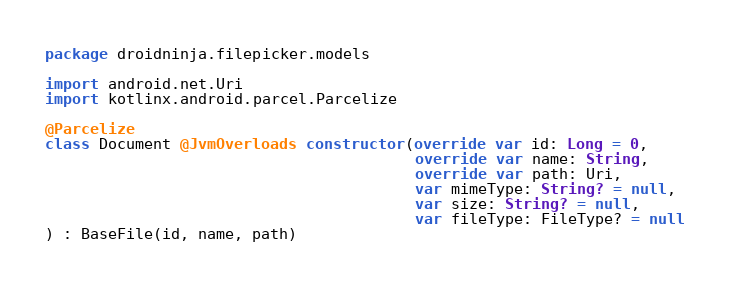Convert code to text. <code><loc_0><loc_0><loc_500><loc_500><_Kotlin_>package droidninja.filepicker.models

import android.net.Uri
import kotlinx.android.parcel.Parcelize

@Parcelize
class Document @JvmOverloads constructor(override var id: Long = 0,
                                         override var name: String,
                                         override var path: Uri,
                                         var mimeType: String? = null,
                                         var size: String? = null,
                                         var fileType: FileType? = null
) : BaseFile(id, name, path)</code> 